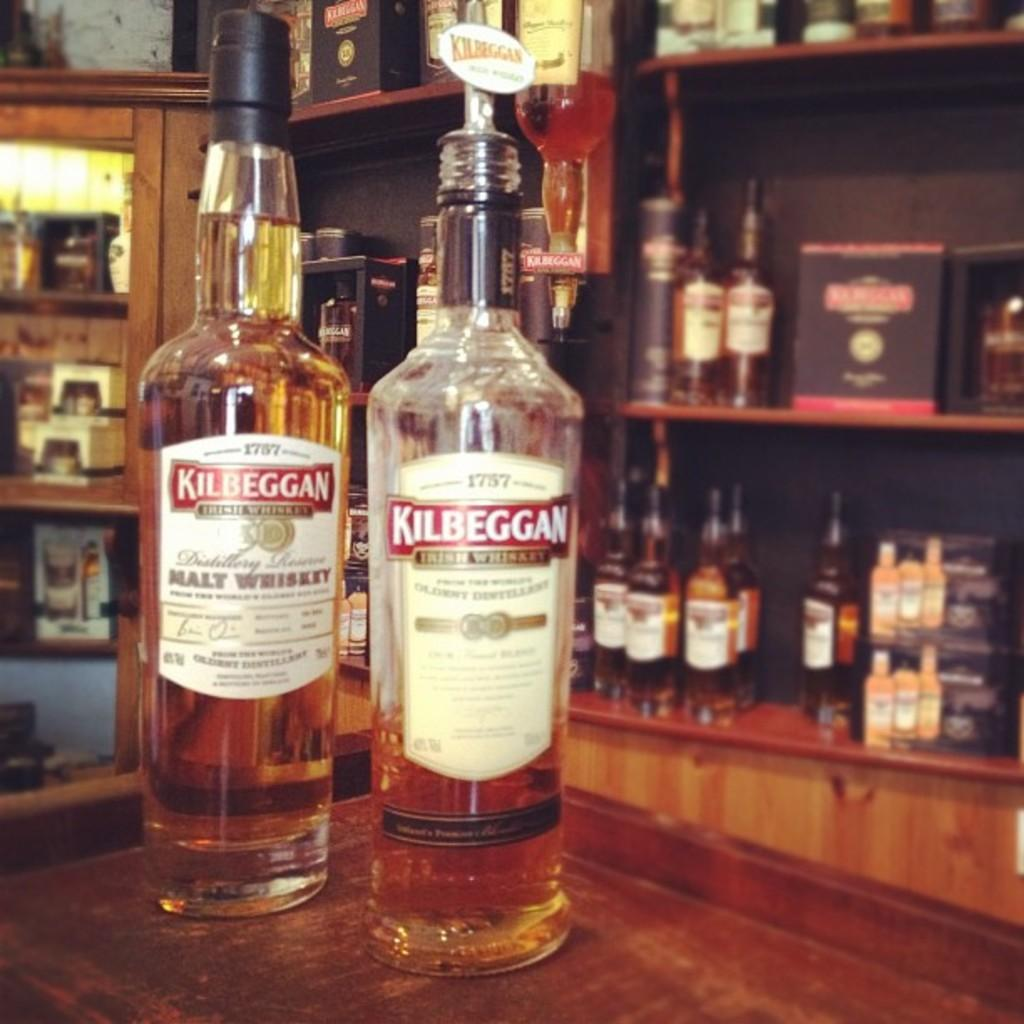<image>
Share a concise interpretation of the image provided. two bottles of Kilbeggan Malt Whiskey on a display 